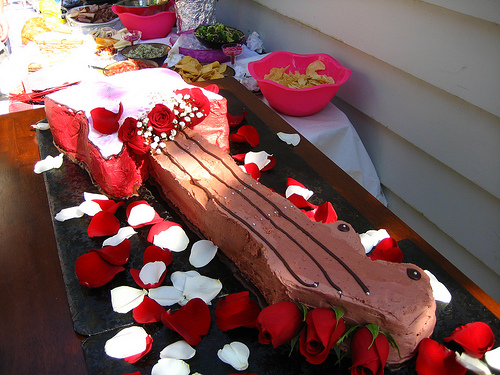<image>
Is there a rose on the cake? Yes. Looking at the image, I can see the rose is positioned on top of the cake, with the cake providing support. 